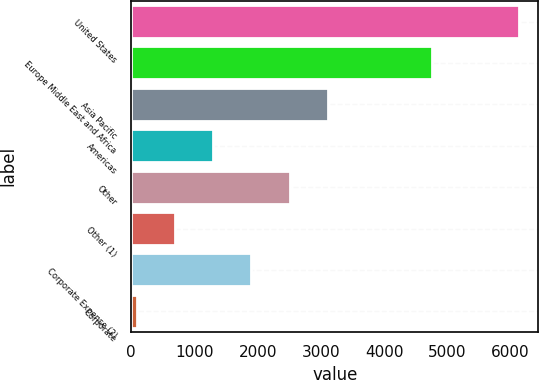Convert chart to OTSL. <chart><loc_0><loc_0><loc_500><loc_500><bar_chart><fcel>United States<fcel>Europe Middle East and Africa<fcel>Asia Pacific<fcel>Americas<fcel>Other<fcel>Other (1)<fcel>Corporate Expense (2)<fcel>Corporate<nl><fcel>6131.7<fcel>4764.1<fcel>3110.5<fcel>1297.78<fcel>2506.26<fcel>693.54<fcel>1902.02<fcel>89.3<nl></chart> 